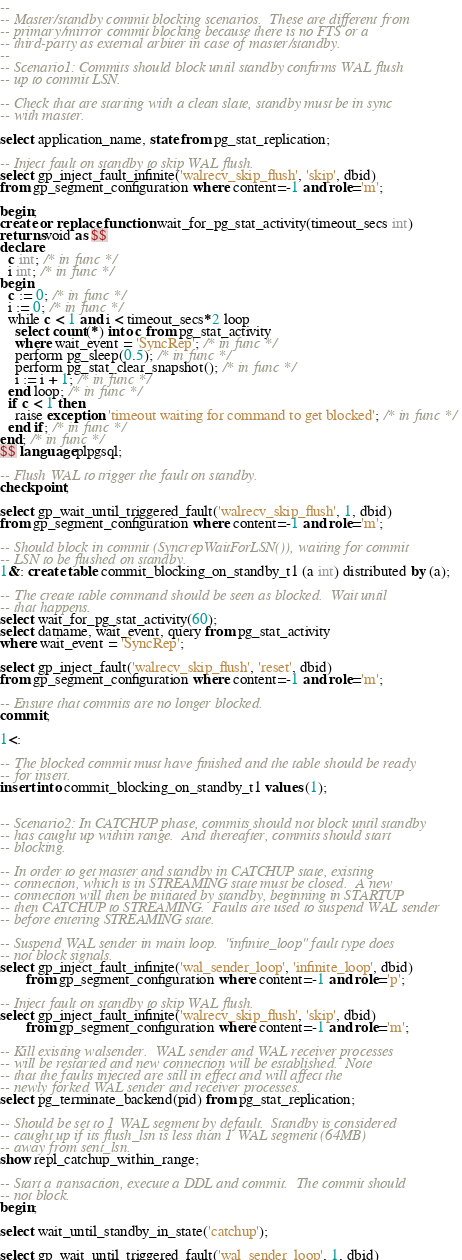Convert code to text. <code><loc_0><loc_0><loc_500><loc_500><_SQL_>--
-- Master/standby commit blocking scenarios.  These are different from
-- primary/mirror commit blocking because there is no FTS or a
-- third-party as external arbiter in case of master/standby.
--
-- Scenario1: Commits should block until standby confirms WAL flush
-- up to commit LSN.

-- Check that are starting with a clean slate, standby must be in sync
-- with master.

select application_name, state from pg_stat_replication;

-- Inject fault on standby to skip WAL flush.
select gp_inject_fault_infinite('walrecv_skip_flush', 'skip', dbid)
from gp_segment_configuration where content=-1 and role='m';

begin;
create or replace function wait_for_pg_stat_activity(timeout_secs int)
returns void as $$
declare
  c int; /* in func */
  i int; /* in func */
begin
  c := 0; /* in func */
  i := 0; /* in func */
  while c < 1 and i < timeout_secs*2 loop
    select count(*) into c from pg_stat_activity
    where wait_event = 'SyncRep'; /* in func */
    perform pg_sleep(0.5); /* in func */
    perform pg_stat_clear_snapshot(); /* in func */
    i := i + 1; /* in func */
  end loop; /* in func */
  if c < 1 then
    raise exception 'timeout waiting for command to get blocked'; /* in func */
  end if; /* in func */
end; /* in func */
$$ language plpgsql;

-- Flush WAL to trigger the fault on standby.
checkpoint;

select gp_wait_until_triggered_fault('walrecv_skip_flush', 1, dbid)
from gp_segment_configuration where content=-1 and role='m';

-- Should block in commit (SyncrepWaitForLSN()), waiting for commit
-- LSN to be flushed on standby.
1&: create table commit_blocking_on_standby_t1 (a int) distributed by (a);

-- The create table command should be seen as blocked.  Wait until
-- that happens.
select wait_for_pg_stat_activity(60);
select datname, wait_event, query from pg_stat_activity
where wait_event = 'SyncRep';

select gp_inject_fault('walrecv_skip_flush', 'reset', dbid)
from gp_segment_configuration where content=-1 and role='m';

-- Ensure that commits are no longer blocked.
commit;

1<:

-- The blocked commit must have finished and the table should be ready
-- for insert.
insert into commit_blocking_on_standby_t1 values (1);


-- Scenario2: In CATCHUP phase, commits should not block until standby
-- has caught up within range.  And thereafter, commits should start
-- blocking.

-- In order to get master and standby in CATCHUP state, existing
-- connection, which is in STREAMING state must be closed.  A new
-- connection will then be initiated by standby, beginning in STARTUP
-- then CATCHUP to STREAMING.  Faults are used to suspend WAL sender
-- before entering STREAMING state.

-- Suspend WAL sender in main loop.  "infinite_loop" fault type does
-- not block signals.
select gp_inject_fault_infinite('wal_sender_loop', 'infinite_loop', dbid)
       from gp_segment_configuration where content=-1 and role='p';

-- Inject fault on standby to skip WAL flush.
select gp_inject_fault_infinite('walrecv_skip_flush', 'skip', dbid)
       from gp_segment_configuration where content=-1 and role='m';

-- Kill existing walsender.  WAL sender and WAL receiver processes
-- will be restarted and new connection will be established.  Note
-- that the faults injected are still in effect and will affect the
-- newly forked WAL sender and receiver processes.
select pg_terminate_backend(pid) from pg_stat_replication;

-- Should be set to 1 WAL segment by default.  Standby is considered
-- caught up if its flush_lsn is less than 1 WAL segment (64MB)
-- away from sent_lsn.
show repl_catchup_within_range;

-- Start a transaction, execute a DDL and commit.  The commit should
-- not block.
begin;

select wait_until_standby_in_state('catchup');

select gp_wait_until_triggered_fault('wal_sender_loop', 1, dbid)</code> 